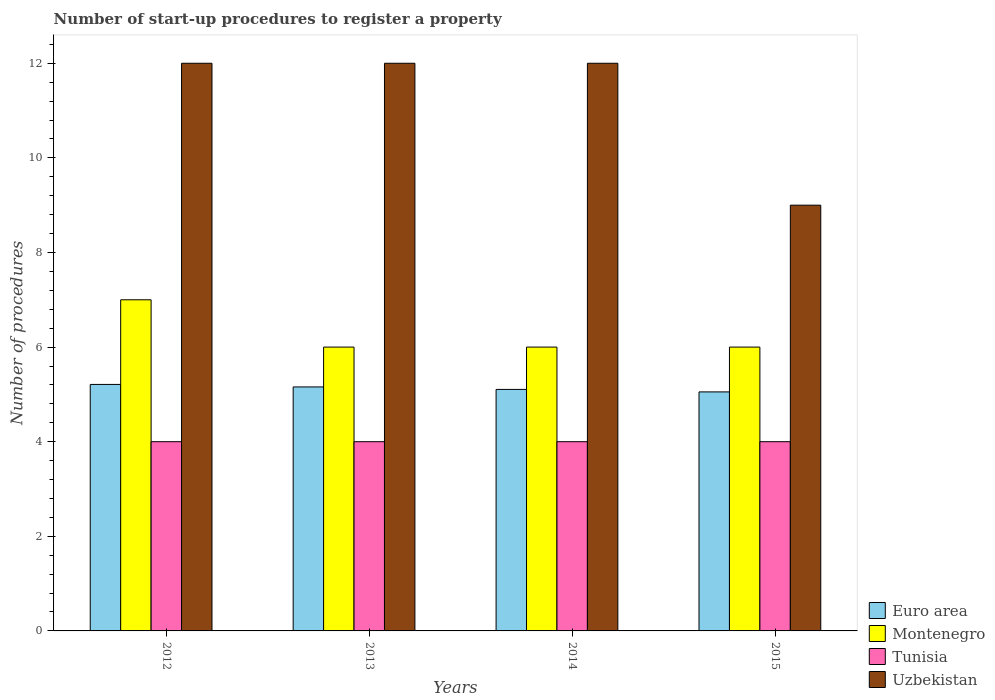How many bars are there on the 1st tick from the right?
Ensure brevity in your answer.  4. What is the label of the 3rd group of bars from the left?
Offer a terse response. 2014. What is the number of procedures required to register a property in Montenegro in 2014?
Your answer should be compact. 6. Across all years, what is the maximum number of procedures required to register a property in Tunisia?
Your answer should be compact. 4. Across all years, what is the minimum number of procedures required to register a property in Euro area?
Offer a very short reply. 5.05. What is the total number of procedures required to register a property in Euro area in the graph?
Offer a terse response. 20.53. What is the average number of procedures required to register a property in Euro area per year?
Offer a very short reply. 5.13. In the year 2012, what is the difference between the number of procedures required to register a property in Uzbekistan and number of procedures required to register a property in Euro area?
Keep it short and to the point. 6.79. In how many years, is the number of procedures required to register a property in Uzbekistan greater than 3.6?
Offer a very short reply. 4. What is the ratio of the number of procedures required to register a property in Euro area in 2013 to that in 2015?
Your answer should be compact. 1.02. Is the difference between the number of procedures required to register a property in Uzbekistan in 2013 and 2014 greater than the difference between the number of procedures required to register a property in Euro area in 2013 and 2014?
Make the answer very short. No. What is the difference between the highest and the second highest number of procedures required to register a property in Euro area?
Offer a terse response. 0.05. What is the difference between the highest and the lowest number of procedures required to register a property in Montenegro?
Keep it short and to the point. 1. In how many years, is the number of procedures required to register a property in Euro area greater than the average number of procedures required to register a property in Euro area taken over all years?
Provide a short and direct response. 2. Is it the case that in every year, the sum of the number of procedures required to register a property in Montenegro and number of procedures required to register a property in Euro area is greater than the sum of number of procedures required to register a property in Tunisia and number of procedures required to register a property in Uzbekistan?
Make the answer very short. Yes. What does the 4th bar from the left in 2012 represents?
Ensure brevity in your answer.  Uzbekistan. What does the 3rd bar from the right in 2015 represents?
Offer a very short reply. Montenegro. Is it the case that in every year, the sum of the number of procedures required to register a property in Montenegro and number of procedures required to register a property in Euro area is greater than the number of procedures required to register a property in Tunisia?
Ensure brevity in your answer.  Yes. How many bars are there?
Ensure brevity in your answer.  16. Are the values on the major ticks of Y-axis written in scientific E-notation?
Keep it short and to the point. No. How are the legend labels stacked?
Make the answer very short. Vertical. What is the title of the graph?
Your response must be concise. Number of start-up procedures to register a property. What is the label or title of the Y-axis?
Provide a short and direct response. Number of procedures. What is the Number of procedures of Euro area in 2012?
Make the answer very short. 5.21. What is the Number of procedures in Montenegro in 2012?
Your answer should be very brief. 7. What is the Number of procedures of Tunisia in 2012?
Offer a very short reply. 4. What is the Number of procedures in Euro area in 2013?
Give a very brief answer. 5.16. What is the Number of procedures of Euro area in 2014?
Provide a succinct answer. 5.11. What is the Number of procedures in Uzbekistan in 2014?
Your answer should be compact. 12. What is the Number of procedures of Euro area in 2015?
Provide a succinct answer. 5.05. What is the Number of procedures in Tunisia in 2015?
Provide a short and direct response. 4. What is the Number of procedures of Uzbekistan in 2015?
Your answer should be compact. 9. Across all years, what is the maximum Number of procedures in Euro area?
Offer a terse response. 5.21. Across all years, what is the maximum Number of procedures of Montenegro?
Your response must be concise. 7. Across all years, what is the minimum Number of procedures in Euro area?
Ensure brevity in your answer.  5.05. Across all years, what is the minimum Number of procedures of Tunisia?
Ensure brevity in your answer.  4. Across all years, what is the minimum Number of procedures of Uzbekistan?
Give a very brief answer. 9. What is the total Number of procedures of Euro area in the graph?
Give a very brief answer. 20.53. What is the total Number of procedures in Tunisia in the graph?
Ensure brevity in your answer.  16. What is the total Number of procedures in Uzbekistan in the graph?
Your answer should be very brief. 45. What is the difference between the Number of procedures in Euro area in 2012 and that in 2013?
Ensure brevity in your answer.  0.05. What is the difference between the Number of procedures in Montenegro in 2012 and that in 2013?
Offer a terse response. 1. What is the difference between the Number of procedures in Tunisia in 2012 and that in 2013?
Provide a succinct answer. 0. What is the difference between the Number of procedures of Euro area in 2012 and that in 2014?
Provide a succinct answer. 0.11. What is the difference between the Number of procedures of Euro area in 2012 and that in 2015?
Provide a short and direct response. 0.16. What is the difference between the Number of procedures of Tunisia in 2012 and that in 2015?
Your response must be concise. 0. What is the difference between the Number of procedures in Uzbekistan in 2012 and that in 2015?
Offer a very short reply. 3. What is the difference between the Number of procedures of Euro area in 2013 and that in 2014?
Offer a terse response. 0.05. What is the difference between the Number of procedures in Uzbekistan in 2013 and that in 2014?
Your response must be concise. 0. What is the difference between the Number of procedures in Euro area in 2013 and that in 2015?
Your response must be concise. 0.11. What is the difference between the Number of procedures of Montenegro in 2013 and that in 2015?
Offer a very short reply. 0. What is the difference between the Number of procedures in Euro area in 2014 and that in 2015?
Give a very brief answer. 0.05. What is the difference between the Number of procedures of Uzbekistan in 2014 and that in 2015?
Keep it short and to the point. 3. What is the difference between the Number of procedures in Euro area in 2012 and the Number of procedures in Montenegro in 2013?
Your answer should be compact. -0.79. What is the difference between the Number of procedures of Euro area in 2012 and the Number of procedures of Tunisia in 2013?
Provide a succinct answer. 1.21. What is the difference between the Number of procedures of Euro area in 2012 and the Number of procedures of Uzbekistan in 2013?
Make the answer very short. -6.79. What is the difference between the Number of procedures of Tunisia in 2012 and the Number of procedures of Uzbekistan in 2013?
Provide a short and direct response. -8. What is the difference between the Number of procedures of Euro area in 2012 and the Number of procedures of Montenegro in 2014?
Ensure brevity in your answer.  -0.79. What is the difference between the Number of procedures of Euro area in 2012 and the Number of procedures of Tunisia in 2014?
Keep it short and to the point. 1.21. What is the difference between the Number of procedures in Euro area in 2012 and the Number of procedures in Uzbekistan in 2014?
Keep it short and to the point. -6.79. What is the difference between the Number of procedures of Tunisia in 2012 and the Number of procedures of Uzbekistan in 2014?
Offer a terse response. -8. What is the difference between the Number of procedures of Euro area in 2012 and the Number of procedures of Montenegro in 2015?
Provide a short and direct response. -0.79. What is the difference between the Number of procedures in Euro area in 2012 and the Number of procedures in Tunisia in 2015?
Your answer should be very brief. 1.21. What is the difference between the Number of procedures in Euro area in 2012 and the Number of procedures in Uzbekistan in 2015?
Keep it short and to the point. -3.79. What is the difference between the Number of procedures in Montenegro in 2012 and the Number of procedures in Tunisia in 2015?
Your response must be concise. 3. What is the difference between the Number of procedures of Tunisia in 2012 and the Number of procedures of Uzbekistan in 2015?
Keep it short and to the point. -5. What is the difference between the Number of procedures of Euro area in 2013 and the Number of procedures of Montenegro in 2014?
Your answer should be very brief. -0.84. What is the difference between the Number of procedures in Euro area in 2013 and the Number of procedures in Tunisia in 2014?
Your response must be concise. 1.16. What is the difference between the Number of procedures in Euro area in 2013 and the Number of procedures in Uzbekistan in 2014?
Give a very brief answer. -6.84. What is the difference between the Number of procedures in Euro area in 2013 and the Number of procedures in Montenegro in 2015?
Give a very brief answer. -0.84. What is the difference between the Number of procedures of Euro area in 2013 and the Number of procedures of Tunisia in 2015?
Your answer should be very brief. 1.16. What is the difference between the Number of procedures in Euro area in 2013 and the Number of procedures in Uzbekistan in 2015?
Keep it short and to the point. -3.84. What is the difference between the Number of procedures of Tunisia in 2013 and the Number of procedures of Uzbekistan in 2015?
Provide a short and direct response. -5. What is the difference between the Number of procedures in Euro area in 2014 and the Number of procedures in Montenegro in 2015?
Your answer should be very brief. -0.89. What is the difference between the Number of procedures in Euro area in 2014 and the Number of procedures in Tunisia in 2015?
Offer a terse response. 1.11. What is the difference between the Number of procedures in Euro area in 2014 and the Number of procedures in Uzbekistan in 2015?
Keep it short and to the point. -3.89. What is the difference between the Number of procedures in Montenegro in 2014 and the Number of procedures in Uzbekistan in 2015?
Your answer should be compact. -3. What is the difference between the Number of procedures of Tunisia in 2014 and the Number of procedures of Uzbekistan in 2015?
Give a very brief answer. -5. What is the average Number of procedures of Euro area per year?
Ensure brevity in your answer.  5.13. What is the average Number of procedures of Montenegro per year?
Provide a short and direct response. 6.25. What is the average Number of procedures in Uzbekistan per year?
Your answer should be compact. 11.25. In the year 2012, what is the difference between the Number of procedures in Euro area and Number of procedures in Montenegro?
Make the answer very short. -1.79. In the year 2012, what is the difference between the Number of procedures in Euro area and Number of procedures in Tunisia?
Your answer should be very brief. 1.21. In the year 2012, what is the difference between the Number of procedures of Euro area and Number of procedures of Uzbekistan?
Provide a short and direct response. -6.79. In the year 2012, what is the difference between the Number of procedures of Tunisia and Number of procedures of Uzbekistan?
Make the answer very short. -8. In the year 2013, what is the difference between the Number of procedures of Euro area and Number of procedures of Montenegro?
Offer a terse response. -0.84. In the year 2013, what is the difference between the Number of procedures in Euro area and Number of procedures in Tunisia?
Give a very brief answer. 1.16. In the year 2013, what is the difference between the Number of procedures in Euro area and Number of procedures in Uzbekistan?
Offer a terse response. -6.84. In the year 2013, what is the difference between the Number of procedures of Montenegro and Number of procedures of Uzbekistan?
Make the answer very short. -6. In the year 2013, what is the difference between the Number of procedures in Tunisia and Number of procedures in Uzbekistan?
Provide a short and direct response. -8. In the year 2014, what is the difference between the Number of procedures in Euro area and Number of procedures in Montenegro?
Your answer should be compact. -0.89. In the year 2014, what is the difference between the Number of procedures of Euro area and Number of procedures of Tunisia?
Provide a short and direct response. 1.11. In the year 2014, what is the difference between the Number of procedures in Euro area and Number of procedures in Uzbekistan?
Your answer should be very brief. -6.89. In the year 2014, what is the difference between the Number of procedures in Montenegro and Number of procedures in Tunisia?
Make the answer very short. 2. In the year 2014, what is the difference between the Number of procedures of Montenegro and Number of procedures of Uzbekistan?
Your response must be concise. -6. In the year 2014, what is the difference between the Number of procedures of Tunisia and Number of procedures of Uzbekistan?
Your answer should be very brief. -8. In the year 2015, what is the difference between the Number of procedures in Euro area and Number of procedures in Montenegro?
Your answer should be compact. -0.95. In the year 2015, what is the difference between the Number of procedures in Euro area and Number of procedures in Tunisia?
Your answer should be very brief. 1.05. In the year 2015, what is the difference between the Number of procedures in Euro area and Number of procedures in Uzbekistan?
Your response must be concise. -3.95. In the year 2015, what is the difference between the Number of procedures in Tunisia and Number of procedures in Uzbekistan?
Your response must be concise. -5. What is the ratio of the Number of procedures in Euro area in 2012 to that in 2013?
Your answer should be very brief. 1.01. What is the ratio of the Number of procedures in Montenegro in 2012 to that in 2013?
Offer a very short reply. 1.17. What is the ratio of the Number of procedures of Euro area in 2012 to that in 2014?
Provide a succinct answer. 1.02. What is the ratio of the Number of procedures in Uzbekistan in 2012 to that in 2014?
Give a very brief answer. 1. What is the ratio of the Number of procedures in Euro area in 2012 to that in 2015?
Your response must be concise. 1.03. What is the ratio of the Number of procedures of Uzbekistan in 2012 to that in 2015?
Keep it short and to the point. 1.33. What is the ratio of the Number of procedures in Euro area in 2013 to that in 2014?
Keep it short and to the point. 1.01. What is the ratio of the Number of procedures of Montenegro in 2013 to that in 2014?
Give a very brief answer. 1. What is the ratio of the Number of procedures of Uzbekistan in 2013 to that in 2014?
Keep it short and to the point. 1. What is the ratio of the Number of procedures in Euro area in 2013 to that in 2015?
Your answer should be compact. 1.02. What is the ratio of the Number of procedures of Montenegro in 2013 to that in 2015?
Your answer should be very brief. 1. What is the ratio of the Number of procedures of Tunisia in 2013 to that in 2015?
Ensure brevity in your answer.  1. What is the ratio of the Number of procedures of Euro area in 2014 to that in 2015?
Give a very brief answer. 1.01. What is the difference between the highest and the second highest Number of procedures of Euro area?
Make the answer very short. 0.05. What is the difference between the highest and the second highest Number of procedures of Montenegro?
Your answer should be very brief. 1. What is the difference between the highest and the second highest Number of procedures in Uzbekistan?
Make the answer very short. 0. What is the difference between the highest and the lowest Number of procedures of Euro area?
Make the answer very short. 0.16. What is the difference between the highest and the lowest Number of procedures in Montenegro?
Provide a short and direct response. 1. What is the difference between the highest and the lowest Number of procedures in Uzbekistan?
Offer a terse response. 3. 